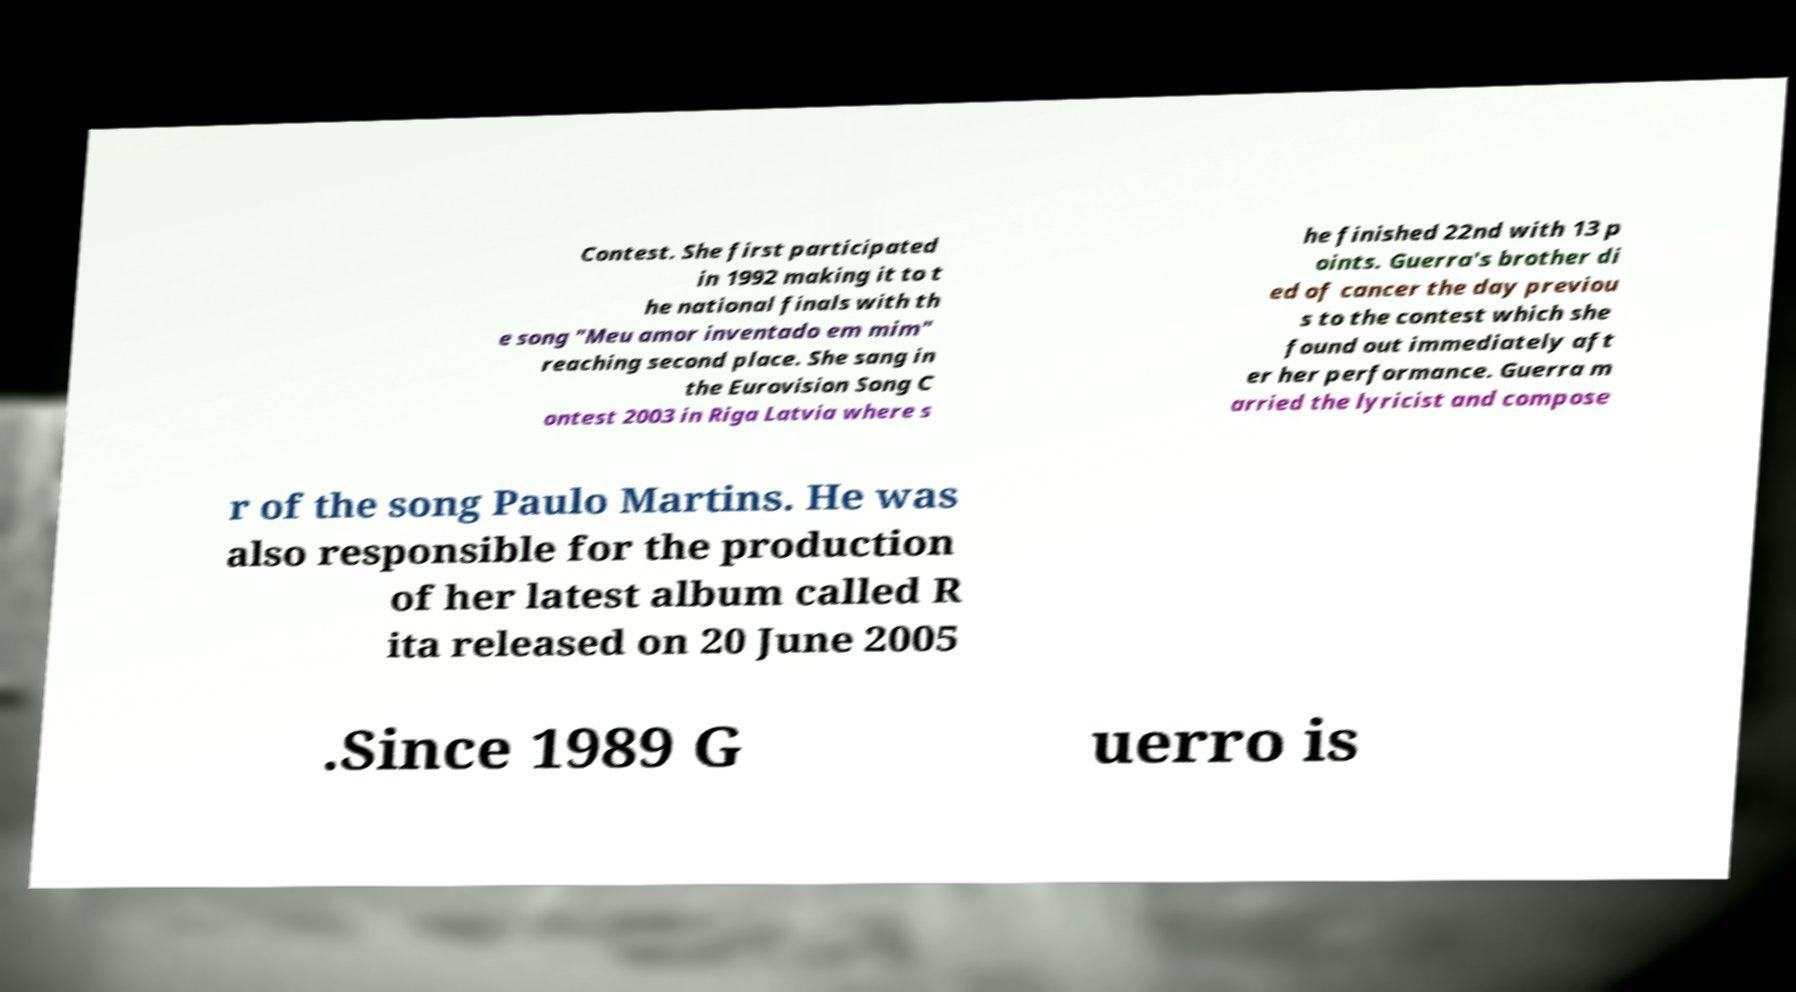Can you accurately transcribe the text from the provided image for me? Contest. She first participated in 1992 making it to t he national finals with th e song "Meu amor inventado em mim" reaching second place. She sang in the Eurovision Song C ontest 2003 in Riga Latvia where s he finished 22nd with 13 p oints. Guerra's brother di ed of cancer the day previou s to the contest which she found out immediately aft er her performance. Guerra m arried the lyricist and compose r of the song Paulo Martins. He was also responsible for the production of her latest album called R ita released on 20 June 2005 .Since 1989 G uerro is 